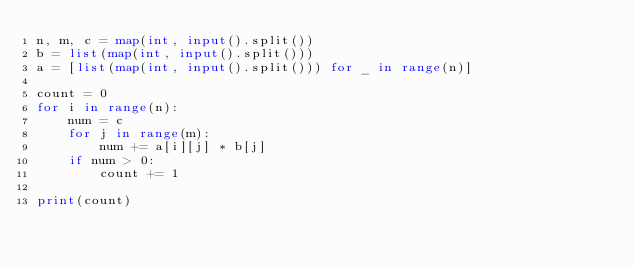Convert code to text. <code><loc_0><loc_0><loc_500><loc_500><_Python_>n, m, c = map(int, input().split())
b = list(map(int, input().split()))
a = [list(map(int, input().split())) for _ in range(n)]

count = 0
for i in range(n):
    num = c
    for j in range(m):
        num += a[i][j] * b[j]
    if num > 0:
        count += 1

print(count)</code> 